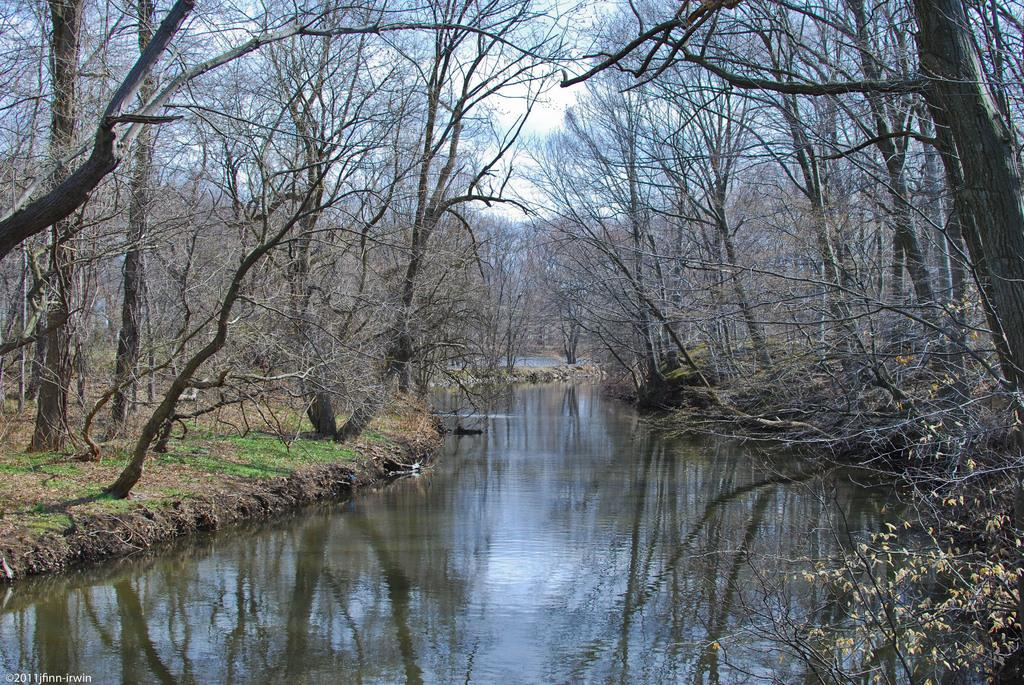What type of vegetation can be seen in the image? There are many trees, plants, and grass visible in the image. What natural feature can be seen in the image? There is a body of water visible in the image. What is visible in the background of the image? The sky is visible in the background of the image. How many feet of cabbage are growing in the image? There is no cabbage present in the image, so it is not possible to determine the number of feet of cabbage growing. 